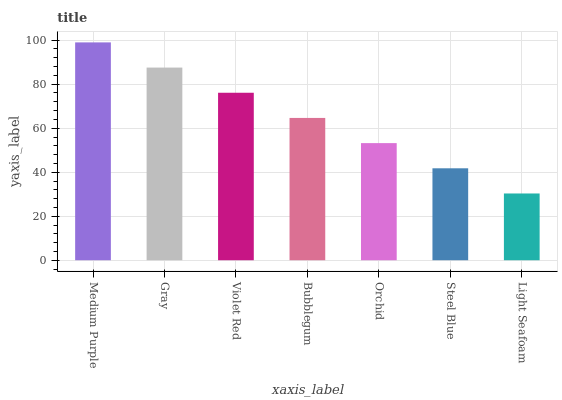Is Gray the minimum?
Answer yes or no. No. Is Gray the maximum?
Answer yes or no. No. Is Medium Purple greater than Gray?
Answer yes or no. Yes. Is Gray less than Medium Purple?
Answer yes or no. Yes. Is Gray greater than Medium Purple?
Answer yes or no. No. Is Medium Purple less than Gray?
Answer yes or no. No. Is Bubblegum the high median?
Answer yes or no. Yes. Is Bubblegum the low median?
Answer yes or no. Yes. Is Light Seafoam the high median?
Answer yes or no. No. Is Light Seafoam the low median?
Answer yes or no. No. 